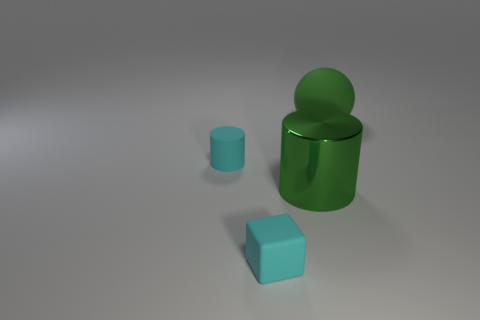Add 1 tiny brown cubes. How many objects exist? 5 Subtract all cubes. How many objects are left? 3 Subtract all cyan matte cylinders. Subtract all big green objects. How many objects are left? 1 Add 3 large green objects. How many large green objects are left? 5 Add 4 tiny cyan matte objects. How many tiny cyan matte objects exist? 6 Subtract 0 yellow blocks. How many objects are left? 4 